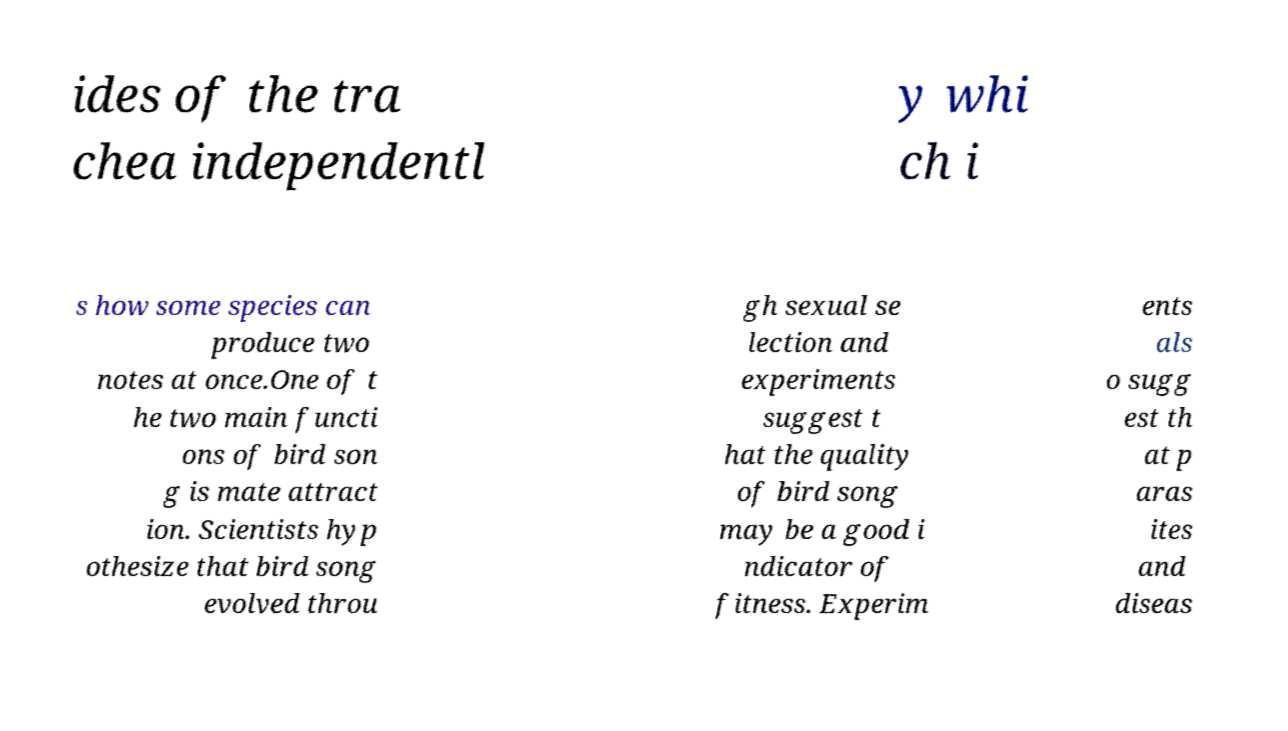There's text embedded in this image that I need extracted. Can you transcribe it verbatim? ides of the tra chea independentl y whi ch i s how some species can produce two notes at once.One of t he two main functi ons of bird son g is mate attract ion. Scientists hyp othesize that bird song evolved throu gh sexual se lection and experiments suggest t hat the quality of bird song may be a good i ndicator of fitness. Experim ents als o sugg est th at p aras ites and diseas 